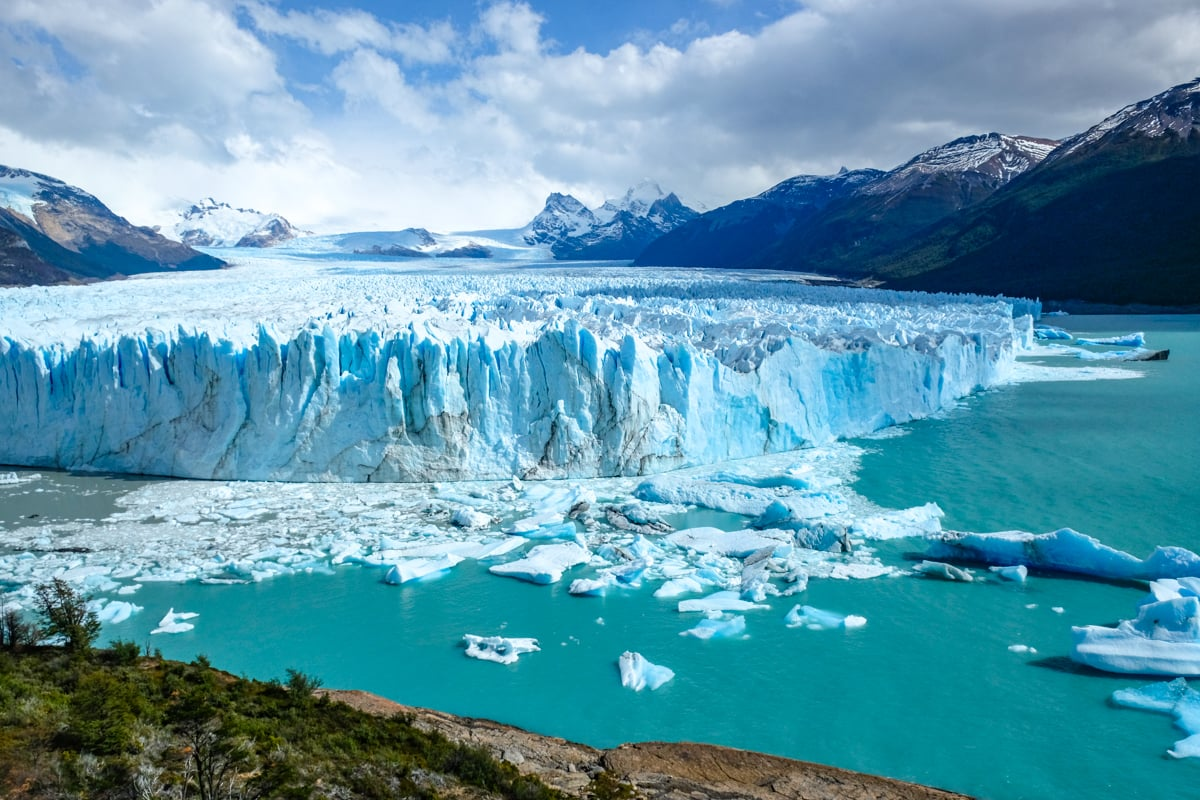Analyze the image in a comprehensive and detailed manner. The image captures an awe-inspiring view of the Perito Moreno Glacier, located in El Calafate, Argentina. The glacier presents a stunning visual with its brilliant blue ice sheets, creating a stark contrast against the lush green vegetation in the foreground and the turquoise waters surrounding it. From a high vantage point, the image provides a sweeping panoramic view that includes the glacier extending towards the horizon, bordered by snow-capped mountains that add to the grandeur of the landscape. Within the water, smaller icebergs—fragments from the glacier itself—are scattered, floating gracefully and enhancing the dynamic quality of the scene. Overhead, the sky is a vibrant blue interspersed with fluffy clouds, further accentuating the pristine beauty of the glacier. This breathtaking image encapsulates the raw, untamed beauty and sheer magnificence of one of nature's most spectacular creations. 